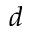<formula> <loc_0><loc_0><loc_500><loc_500>d</formula> 